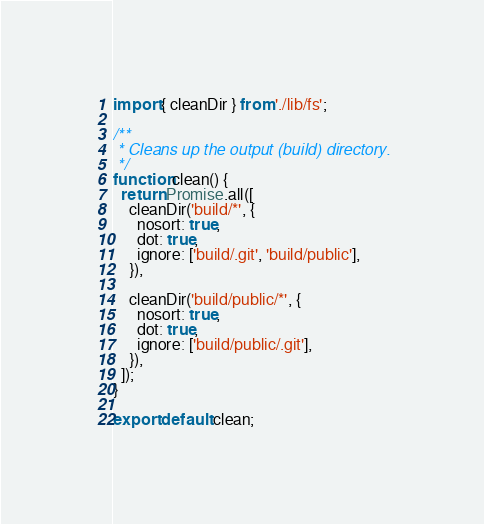Convert code to text. <code><loc_0><loc_0><loc_500><loc_500><_JavaScript_>import { cleanDir } from './lib/fs';

/**
 * Cleans up the output (build) directory.
 */
function clean() {
  return Promise.all([
    cleanDir('build/*', {
      nosort: true,
      dot: true,
      ignore: ['build/.git', 'build/public'],
    }),

    cleanDir('build/public/*', {
      nosort: true,
      dot: true,
      ignore: ['build/public/.git'],
    }),
  ]);
}

export default clean;
</code> 